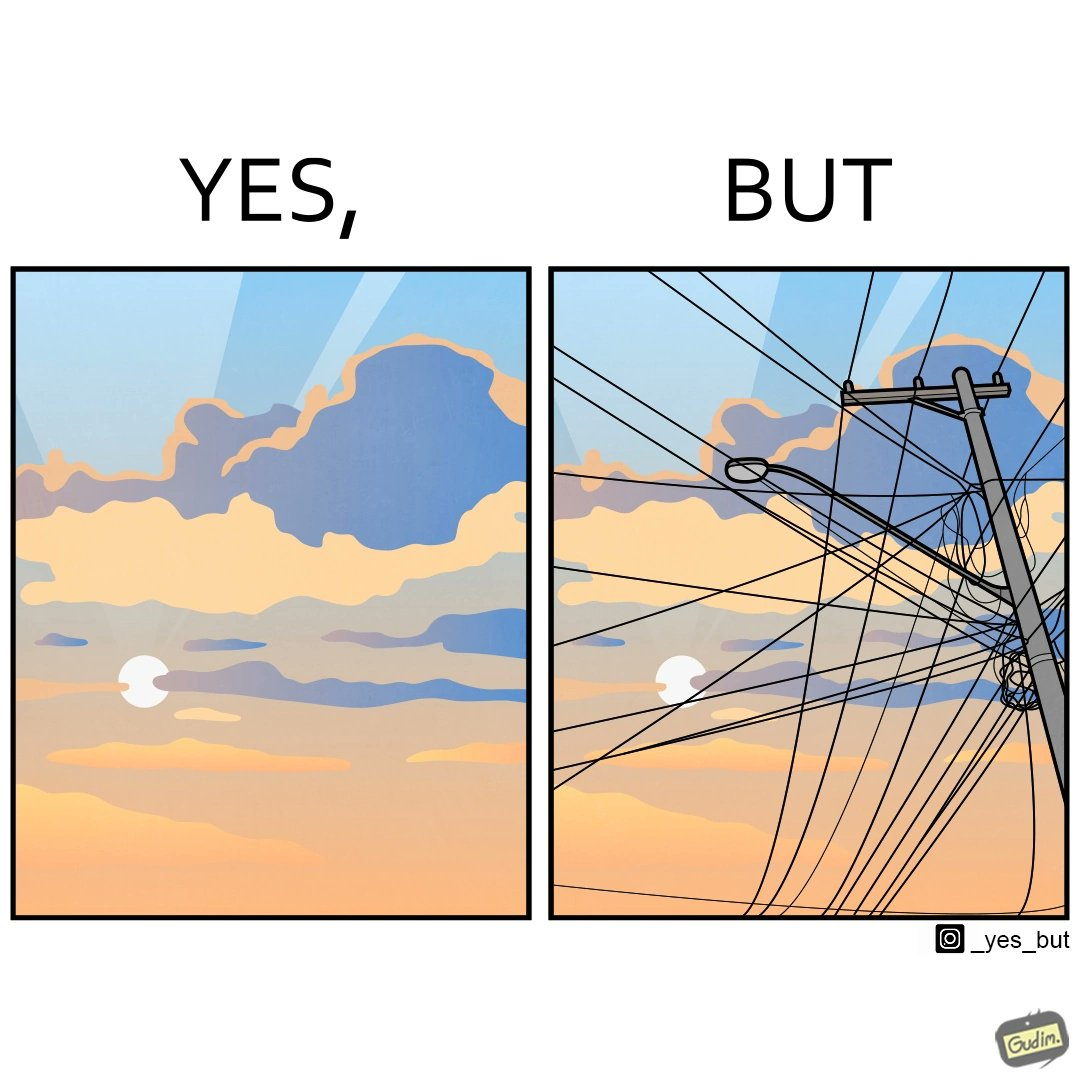Is this a satirical image? Yes, this image is satirical. 